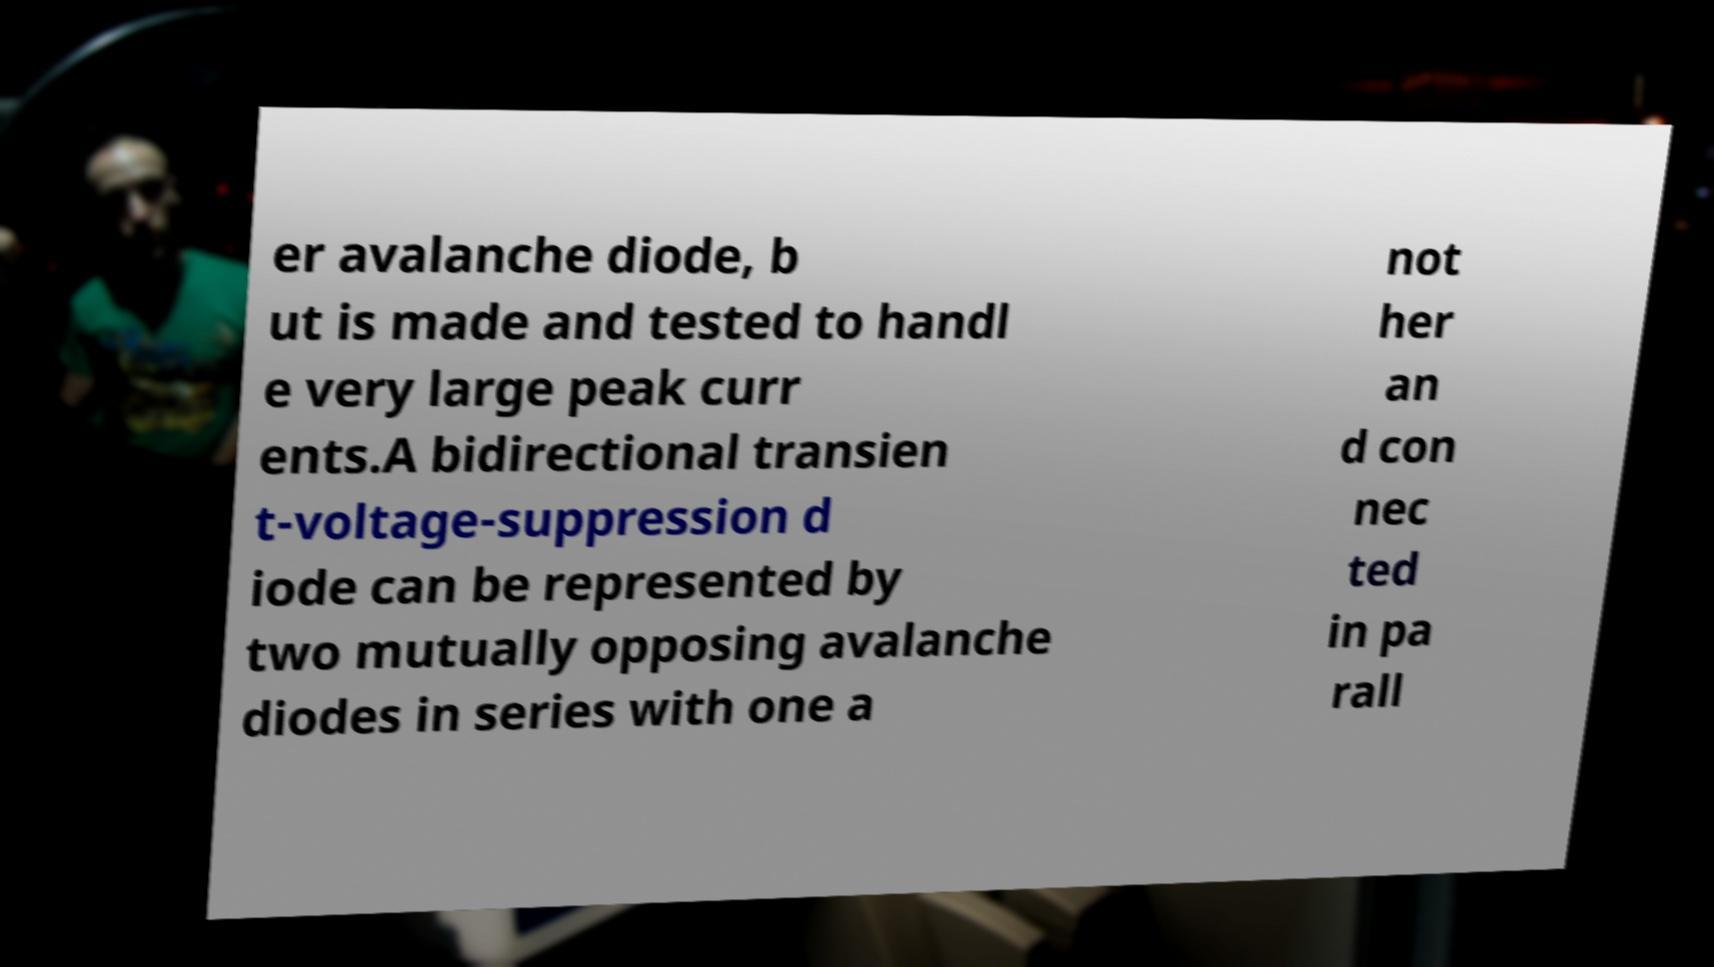There's text embedded in this image that I need extracted. Can you transcribe it verbatim? er avalanche diode, b ut is made and tested to handl e very large peak curr ents.A bidirectional transien t-voltage-suppression d iode can be represented by two mutually opposing avalanche diodes in series with one a not her an d con nec ted in pa rall 